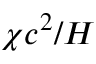<formula> <loc_0><loc_0><loc_500><loc_500>\chi c ^ { 2 } / H</formula> 